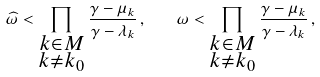<formula> <loc_0><loc_0><loc_500><loc_500>\widehat { \omega } < \prod _ { \substack { k \in M \\ k \ne k _ { 0 } } } \frac { \gamma - \mu _ { k } } { \gamma - \lambda _ { k } } \, , \quad \omega < \prod _ { \substack { k \in M \\ k \ne k _ { 0 } } } \frac { \gamma - \mu _ { k } } { \gamma - \lambda _ { k } } \, ,</formula> 